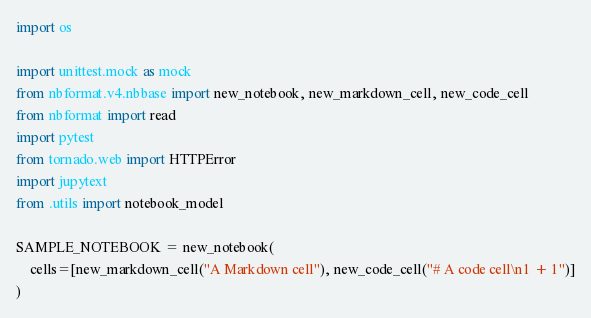Convert code to text. <code><loc_0><loc_0><loc_500><loc_500><_Python_>import os

import unittest.mock as mock
from nbformat.v4.nbbase import new_notebook, new_markdown_cell, new_code_cell
from nbformat import read
import pytest
from tornado.web import HTTPError
import jupytext
from .utils import notebook_model

SAMPLE_NOTEBOOK = new_notebook(
    cells=[new_markdown_cell("A Markdown cell"), new_code_cell("# A code cell\n1 + 1")]
)

</code> 